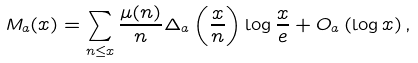<formula> <loc_0><loc_0><loc_500><loc_500>M _ { a } ( x ) = \sum _ { n \leq x } \frac { \mu ( n ) } { n } \Delta _ { a } \left ( \frac { x } { n } \right ) \log \frac { x } { e } + O _ { a } \left ( \log x \right ) ,</formula> 